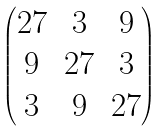Convert formula to latex. <formula><loc_0><loc_0><loc_500><loc_500>\begin{pmatrix} 2 7 & 3 & 9 \\ 9 & 2 7 & 3 \\ 3 & 9 & 2 7 \end{pmatrix}</formula> 